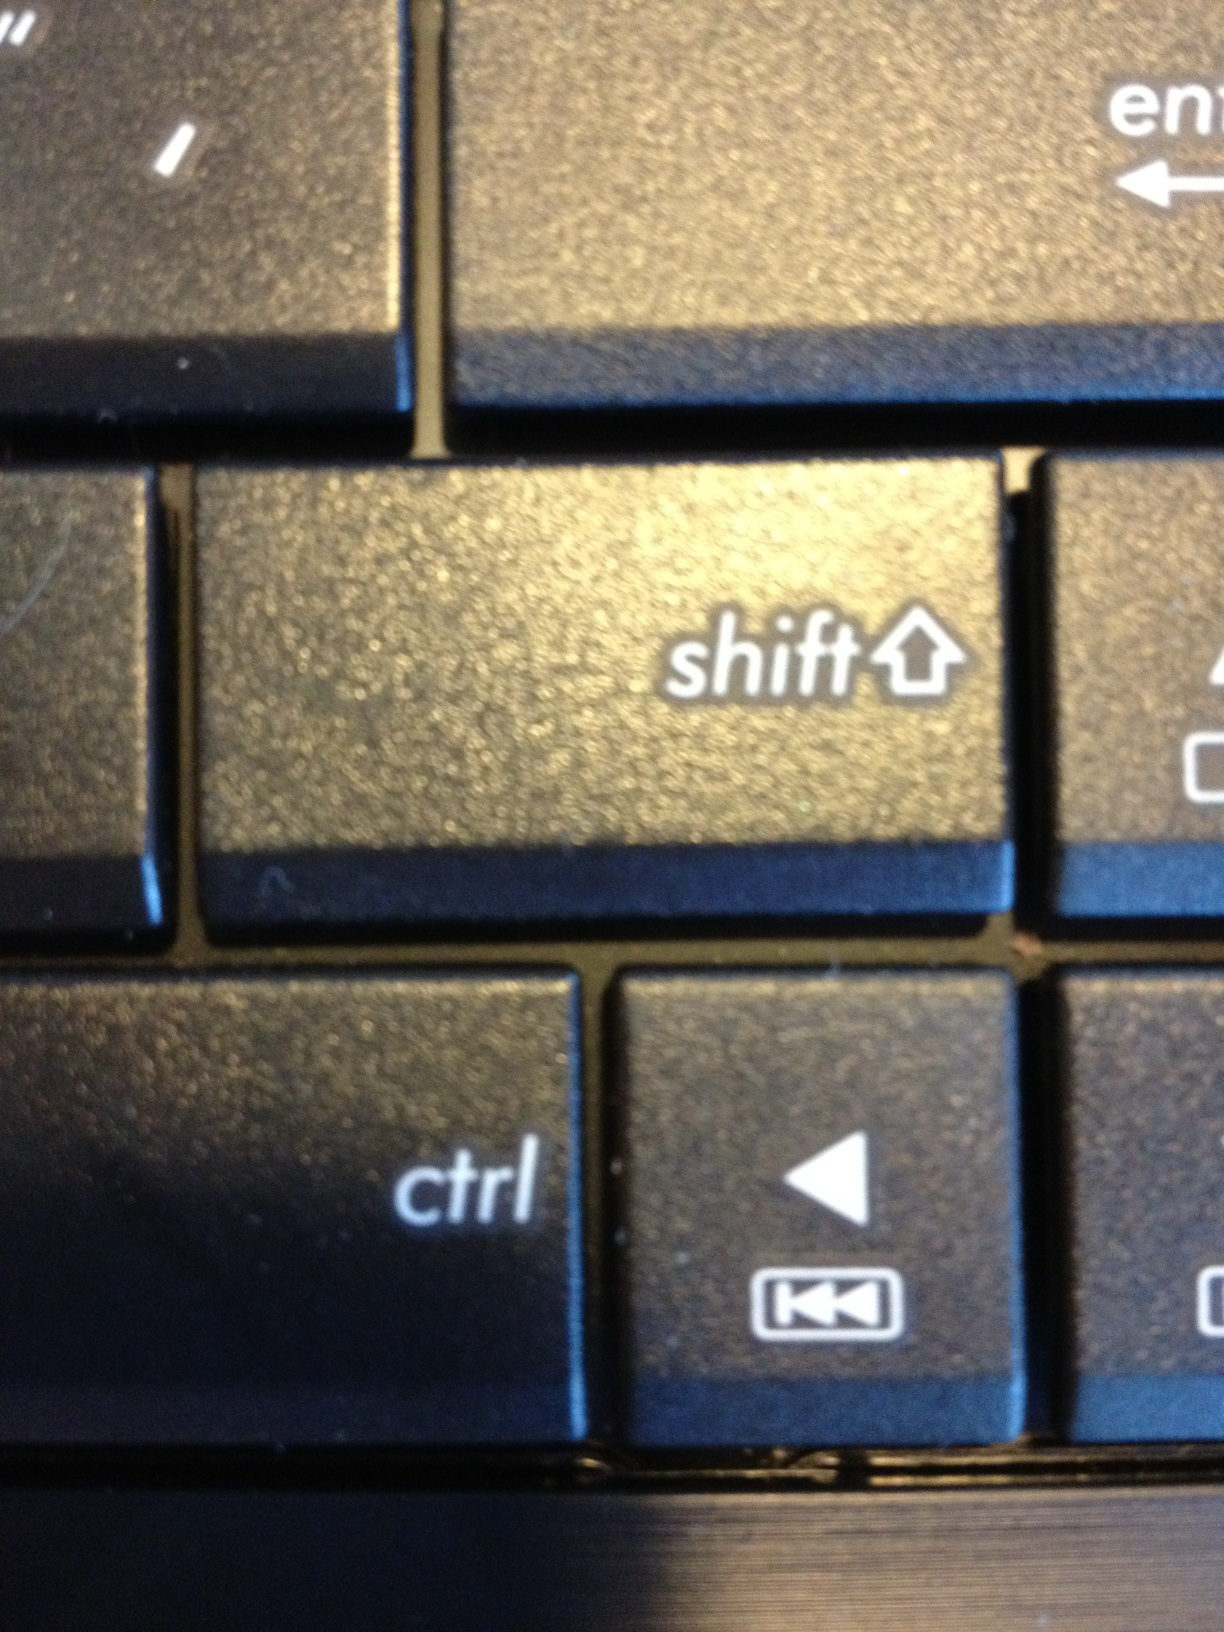What might someone be doing with a keyboard like this? A keyboard like this is most likely to be used for everyday computing tasks such as typing documents, browsing the internet, programming, or gaming. The wear on the keys suggests it is used regularly, which could imply that the owner is either a professional who works extensively with computers or an enthusiast engaging in activities that require frequent keyboard input. 